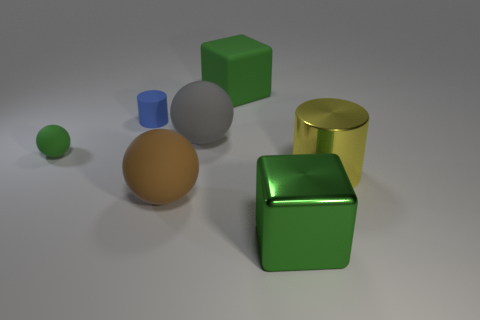There is a large matte ball that is behind the yellow metallic cylinder; what color is it? gray 